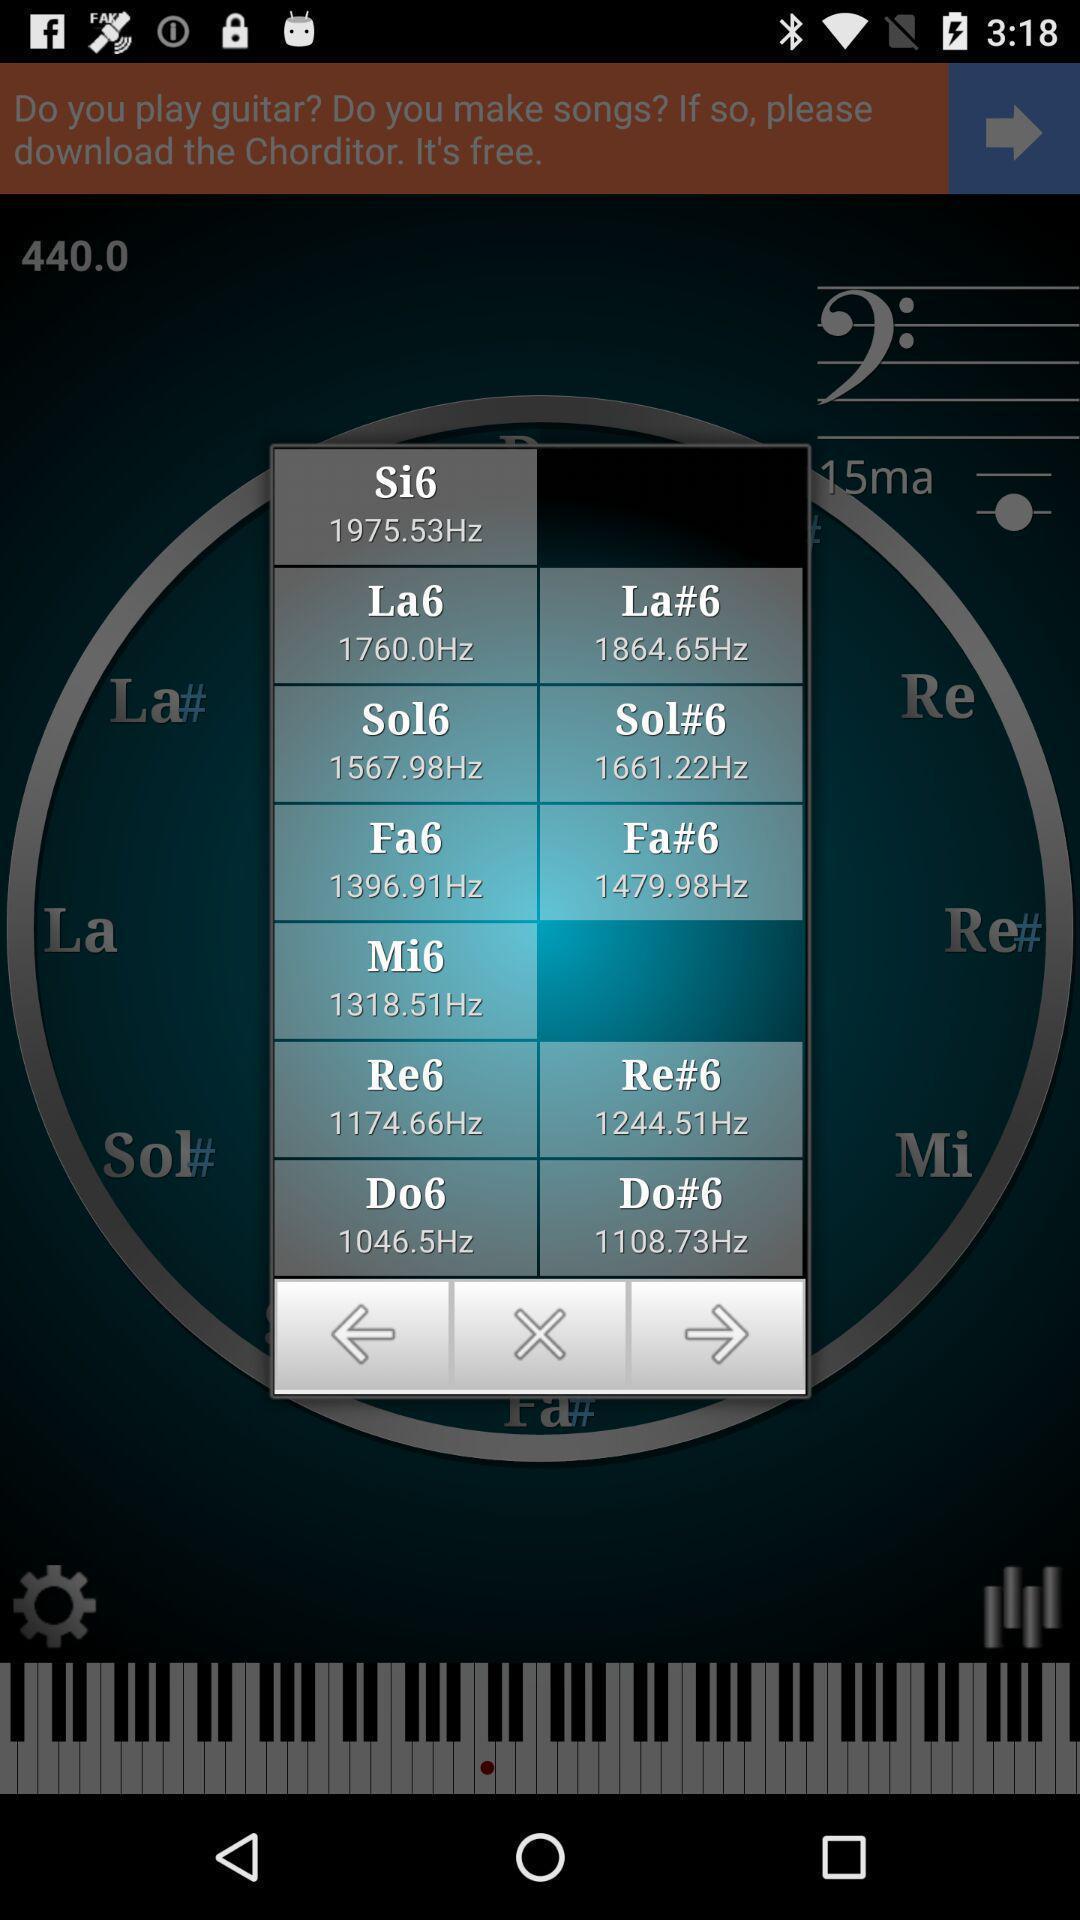Describe the content in this image. Popup displaying frequencies to select on a musical learning app. 